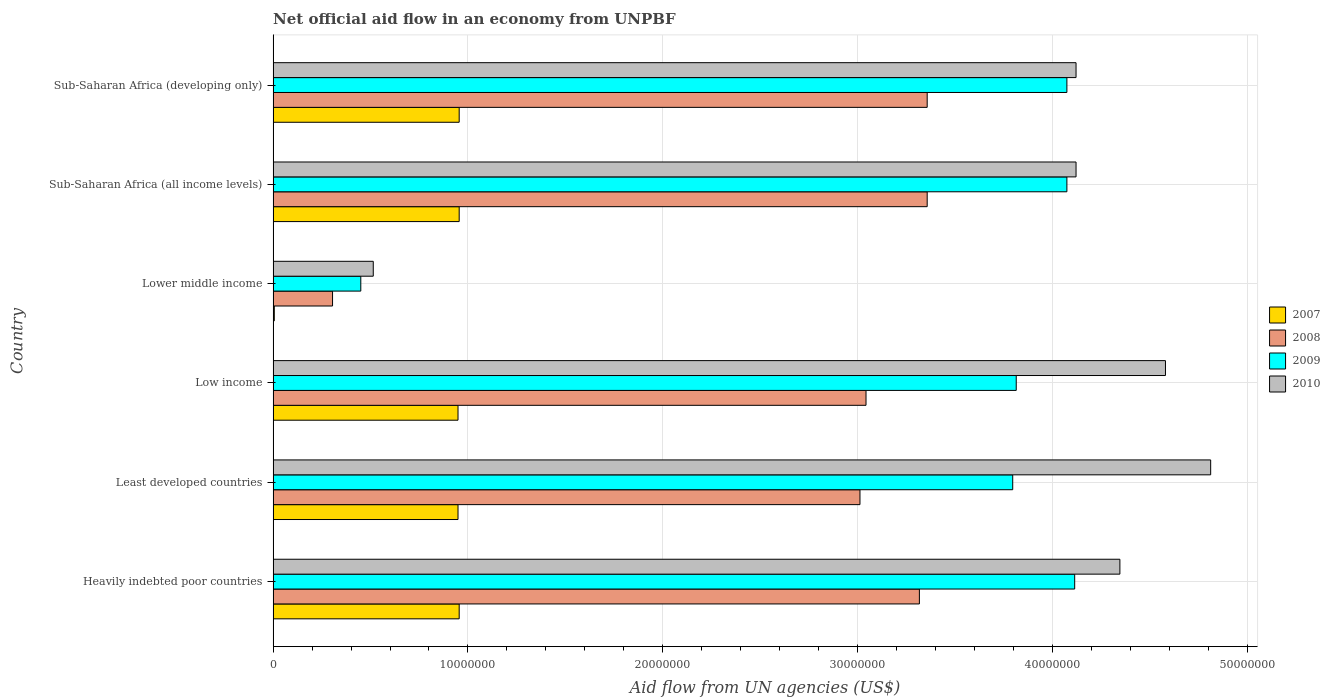How many groups of bars are there?
Your answer should be compact. 6. Are the number of bars per tick equal to the number of legend labels?
Offer a very short reply. Yes. Are the number of bars on each tick of the Y-axis equal?
Offer a terse response. Yes. How many bars are there on the 4th tick from the top?
Offer a terse response. 4. What is the net official aid flow in 2007 in Sub-Saharan Africa (developing only)?
Your answer should be compact. 9.55e+06. Across all countries, what is the maximum net official aid flow in 2010?
Give a very brief answer. 4.81e+07. Across all countries, what is the minimum net official aid flow in 2009?
Ensure brevity in your answer.  4.50e+06. In which country was the net official aid flow in 2010 maximum?
Offer a very short reply. Least developed countries. In which country was the net official aid flow in 2010 minimum?
Your answer should be very brief. Lower middle income. What is the total net official aid flow in 2008 in the graph?
Provide a short and direct response. 1.64e+08. What is the difference between the net official aid flow in 2007 in Low income and that in Sub-Saharan Africa (all income levels)?
Provide a succinct answer. -6.00e+04. What is the difference between the net official aid flow in 2007 in Heavily indebted poor countries and the net official aid flow in 2009 in Low income?
Your answer should be very brief. -2.86e+07. What is the average net official aid flow in 2010 per country?
Give a very brief answer. 3.75e+07. What is the difference between the net official aid flow in 2010 and net official aid flow in 2009 in Lower middle income?
Provide a short and direct response. 6.40e+05. In how many countries, is the net official aid flow in 2007 greater than 28000000 US$?
Offer a terse response. 0. What is the ratio of the net official aid flow in 2010 in Heavily indebted poor countries to that in Least developed countries?
Make the answer very short. 0.9. Is the net official aid flow in 2010 in Heavily indebted poor countries less than that in Low income?
Provide a short and direct response. Yes. Is the difference between the net official aid flow in 2010 in Sub-Saharan Africa (all income levels) and Sub-Saharan Africa (developing only) greater than the difference between the net official aid flow in 2009 in Sub-Saharan Africa (all income levels) and Sub-Saharan Africa (developing only)?
Your response must be concise. No. What is the difference between the highest and the second highest net official aid flow in 2010?
Your answer should be compact. 2.32e+06. What is the difference between the highest and the lowest net official aid flow in 2010?
Your answer should be compact. 4.30e+07. Is the sum of the net official aid flow in 2009 in Lower middle income and Sub-Saharan Africa (all income levels) greater than the maximum net official aid flow in 2010 across all countries?
Give a very brief answer. No. How many bars are there?
Offer a terse response. 24. What is the difference between two consecutive major ticks on the X-axis?
Provide a short and direct response. 1.00e+07. Are the values on the major ticks of X-axis written in scientific E-notation?
Your answer should be very brief. No. Does the graph contain any zero values?
Ensure brevity in your answer.  No. How are the legend labels stacked?
Offer a terse response. Vertical. What is the title of the graph?
Offer a very short reply. Net official aid flow in an economy from UNPBF. Does "1999" appear as one of the legend labels in the graph?
Your response must be concise. No. What is the label or title of the X-axis?
Offer a terse response. Aid flow from UN agencies (US$). What is the label or title of the Y-axis?
Provide a succinct answer. Country. What is the Aid flow from UN agencies (US$) of 2007 in Heavily indebted poor countries?
Make the answer very short. 9.55e+06. What is the Aid flow from UN agencies (US$) in 2008 in Heavily indebted poor countries?
Offer a very short reply. 3.32e+07. What is the Aid flow from UN agencies (US$) in 2009 in Heavily indebted poor countries?
Give a very brief answer. 4.11e+07. What is the Aid flow from UN agencies (US$) of 2010 in Heavily indebted poor countries?
Keep it short and to the point. 4.35e+07. What is the Aid flow from UN agencies (US$) in 2007 in Least developed countries?
Your response must be concise. 9.49e+06. What is the Aid flow from UN agencies (US$) of 2008 in Least developed countries?
Your answer should be compact. 3.01e+07. What is the Aid flow from UN agencies (US$) of 2009 in Least developed countries?
Your answer should be very brief. 3.80e+07. What is the Aid flow from UN agencies (US$) of 2010 in Least developed countries?
Offer a very short reply. 4.81e+07. What is the Aid flow from UN agencies (US$) in 2007 in Low income?
Keep it short and to the point. 9.49e+06. What is the Aid flow from UN agencies (US$) of 2008 in Low income?
Provide a short and direct response. 3.04e+07. What is the Aid flow from UN agencies (US$) of 2009 in Low income?
Provide a short and direct response. 3.81e+07. What is the Aid flow from UN agencies (US$) of 2010 in Low income?
Offer a terse response. 4.58e+07. What is the Aid flow from UN agencies (US$) of 2008 in Lower middle income?
Give a very brief answer. 3.05e+06. What is the Aid flow from UN agencies (US$) in 2009 in Lower middle income?
Give a very brief answer. 4.50e+06. What is the Aid flow from UN agencies (US$) in 2010 in Lower middle income?
Offer a terse response. 5.14e+06. What is the Aid flow from UN agencies (US$) of 2007 in Sub-Saharan Africa (all income levels)?
Offer a terse response. 9.55e+06. What is the Aid flow from UN agencies (US$) of 2008 in Sub-Saharan Africa (all income levels)?
Give a very brief answer. 3.36e+07. What is the Aid flow from UN agencies (US$) of 2009 in Sub-Saharan Africa (all income levels)?
Provide a short and direct response. 4.07e+07. What is the Aid flow from UN agencies (US$) in 2010 in Sub-Saharan Africa (all income levels)?
Your answer should be compact. 4.12e+07. What is the Aid flow from UN agencies (US$) of 2007 in Sub-Saharan Africa (developing only)?
Your response must be concise. 9.55e+06. What is the Aid flow from UN agencies (US$) in 2008 in Sub-Saharan Africa (developing only)?
Keep it short and to the point. 3.36e+07. What is the Aid flow from UN agencies (US$) of 2009 in Sub-Saharan Africa (developing only)?
Make the answer very short. 4.07e+07. What is the Aid flow from UN agencies (US$) of 2010 in Sub-Saharan Africa (developing only)?
Give a very brief answer. 4.12e+07. Across all countries, what is the maximum Aid flow from UN agencies (US$) of 2007?
Give a very brief answer. 9.55e+06. Across all countries, what is the maximum Aid flow from UN agencies (US$) in 2008?
Give a very brief answer. 3.36e+07. Across all countries, what is the maximum Aid flow from UN agencies (US$) of 2009?
Ensure brevity in your answer.  4.11e+07. Across all countries, what is the maximum Aid flow from UN agencies (US$) in 2010?
Offer a terse response. 4.81e+07. Across all countries, what is the minimum Aid flow from UN agencies (US$) in 2008?
Keep it short and to the point. 3.05e+06. Across all countries, what is the minimum Aid flow from UN agencies (US$) of 2009?
Keep it short and to the point. 4.50e+06. Across all countries, what is the minimum Aid flow from UN agencies (US$) in 2010?
Give a very brief answer. 5.14e+06. What is the total Aid flow from UN agencies (US$) in 2007 in the graph?
Make the answer very short. 4.77e+07. What is the total Aid flow from UN agencies (US$) of 2008 in the graph?
Provide a succinct answer. 1.64e+08. What is the total Aid flow from UN agencies (US$) in 2009 in the graph?
Keep it short and to the point. 2.03e+08. What is the total Aid flow from UN agencies (US$) of 2010 in the graph?
Ensure brevity in your answer.  2.25e+08. What is the difference between the Aid flow from UN agencies (US$) in 2007 in Heavily indebted poor countries and that in Least developed countries?
Your answer should be very brief. 6.00e+04. What is the difference between the Aid flow from UN agencies (US$) of 2008 in Heavily indebted poor countries and that in Least developed countries?
Provide a short and direct response. 3.05e+06. What is the difference between the Aid flow from UN agencies (US$) of 2009 in Heavily indebted poor countries and that in Least developed countries?
Your answer should be compact. 3.18e+06. What is the difference between the Aid flow from UN agencies (US$) in 2010 in Heavily indebted poor countries and that in Least developed countries?
Offer a very short reply. -4.66e+06. What is the difference between the Aid flow from UN agencies (US$) of 2007 in Heavily indebted poor countries and that in Low income?
Make the answer very short. 6.00e+04. What is the difference between the Aid flow from UN agencies (US$) in 2008 in Heavily indebted poor countries and that in Low income?
Your response must be concise. 2.74e+06. What is the difference between the Aid flow from UN agencies (US$) of 2009 in Heavily indebted poor countries and that in Low income?
Keep it short and to the point. 3.00e+06. What is the difference between the Aid flow from UN agencies (US$) of 2010 in Heavily indebted poor countries and that in Low income?
Your answer should be very brief. -2.34e+06. What is the difference between the Aid flow from UN agencies (US$) in 2007 in Heavily indebted poor countries and that in Lower middle income?
Offer a terse response. 9.49e+06. What is the difference between the Aid flow from UN agencies (US$) of 2008 in Heavily indebted poor countries and that in Lower middle income?
Your answer should be compact. 3.01e+07. What is the difference between the Aid flow from UN agencies (US$) in 2009 in Heavily indebted poor countries and that in Lower middle income?
Offer a very short reply. 3.66e+07. What is the difference between the Aid flow from UN agencies (US$) of 2010 in Heavily indebted poor countries and that in Lower middle income?
Your answer should be very brief. 3.83e+07. What is the difference between the Aid flow from UN agencies (US$) of 2008 in Heavily indebted poor countries and that in Sub-Saharan Africa (all income levels)?
Offer a terse response. -4.00e+05. What is the difference between the Aid flow from UN agencies (US$) in 2010 in Heavily indebted poor countries and that in Sub-Saharan Africa (all income levels)?
Keep it short and to the point. 2.25e+06. What is the difference between the Aid flow from UN agencies (US$) in 2007 in Heavily indebted poor countries and that in Sub-Saharan Africa (developing only)?
Keep it short and to the point. 0. What is the difference between the Aid flow from UN agencies (US$) of 2008 in Heavily indebted poor countries and that in Sub-Saharan Africa (developing only)?
Ensure brevity in your answer.  -4.00e+05. What is the difference between the Aid flow from UN agencies (US$) of 2010 in Heavily indebted poor countries and that in Sub-Saharan Africa (developing only)?
Offer a very short reply. 2.25e+06. What is the difference between the Aid flow from UN agencies (US$) of 2007 in Least developed countries and that in Low income?
Offer a terse response. 0. What is the difference between the Aid flow from UN agencies (US$) in 2008 in Least developed countries and that in Low income?
Offer a terse response. -3.10e+05. What is the difference between the Aid flow from UN agencies (US$) in 2009 in Least developed countries and that in Low income?
Give a very brief answer. -1.80e+05. What is the difference between the Aid flow from UN agencies (US$) in 2010 in Least developed countries and that in Low income?
Your answer should be compact. 2.32e+06. What is the difference between the Aid flow from UN agencies (US$) of 2007 in Least developed countries and that in Lower middle income?
Your response must be concise. 9.43e+06. What is the difference between the Aid flow from UN agencies (US$) of 2008 in Least developed countries and that in Lower middle income?
Your response must be concise. 2.71e+07. What is the difference between the Aid flow from UN agencies (US$) in 2009 in Least developed countries and that in Lower middle income?
Your answer should be compact. 3.35e+07. What is the difference between the Aid flow from UN agencies (US$) of 2010 in Least developed countries and that in Lower middle income?
Offer a very short reply. 4.30e+07. What is the difference between the Aid flow from UN agencies (US$) in 2007 in Least developed countries and that in Sub-Saharan Africa (all income levels)?
Your answer should be compact. -6.00e+04. What is the difference between the Aid flow from UN agencies (US$) in 2008 in Least developed countries and that in Sub-Saharan Africa (all income levels)?
Make the answer very short. -3.45e+06. What is the difference between the Aid flow from UN agencies (US$) in 2009 in Least developed countries and that in Sub-Saharan Africa (all income levels)?
Your answer should be very brief. -2.78e+06. What is the difference between the Aid flow from UN agencies (US$) in 2010 in Least developed countries and that in Sub-Saharan Africa (all income levels)?
Your answer should be very brief. 6.91e+06. What is the difference between the Aid flow from UN agencies (US$) of 2007 in Least developed countries and that in Sub-Saharan Africa (developing only)?
Keep it short and to the point. -6.00e+04. What is the difference between the Aid flow from UN agencies (US$) of 2008 in Least developed countries and that in Sub-Saharan Africa (developing only)?
Offer a very short reply. -3.45e+06. What is the difference between the Aid flow from UN agencies (US$) of 2009 in Least developed countries and that in Sub-Saharan Africa (developing only)?
Provide a short and direct response. -2.78e+06. What is the difference between the Aid flow from UN agencies (US$) of 2010 in Least developed countries and that in Sub-Saharan Africa (developing only)?
Offer a very short reply. 6.91e+06. What is the difference between the Aid flow from UN agencies (US$) of 2007 in Low income and that in Lower middle income?
Provide a succinct answer. 9.43e+06. What is the difference between the Aid flow from UN agencies (US$) in 2008 in Low income and that in Lower middle income?
Ensure brevity in your answer.  2.74e+07. What is the difference between the Aid flow from UN agencies (US$) in 2009 in Low income and that in Lower middle income?
Make the answer very short. 3.36e+07. What is the difference between the Aid flow from UN agencies (US$) of 2010 in Low income and that in Lower middle income?
Offer a terse response. 4.07e+07. What is the difference between the Aid flow from UN agencies (US$) of 2008 in Low income and that in Sub-Saharan Africa (all income levels)?
Make the answer very short. -3.14e+06. What is the difference between the Aid flow from UN agencies (US$) in 2009 in Low income and that in Sub-Saharan Africa (all income levels)?
Ensure brevity in your answer.  -2.60e+06. What is the difference between the Aid flow from UN agencies (US$) in 2010 in Low income and that in Sub-Saharan Africa (all income levels)?
Make the answer very short. 4.59e+06. What is the difference between the Aid flow from UN agencies (US$) in 2007 in Low income and that in Sub-Saharan Africa (developing only)?
Provide a short and direct response. -6.00e+04. What is the difference between the Aid flow from UN agencies (US$) of 2008 in Low income and that in Sub-Saharan Africa (developing only)?
Offer a very short reply. -3.14e+06. What is the difference between the Aid flow from UN agencies (US$) in 2009 in Low income and that in Sub-Saharan Africa (developing only)?
Ensure brevity in your answer.  -2.60e+06. What is the difference between the Aid flow from UN agencies (US$) in 2010 in Low income and that in Sub-Saharan Africa (developing only)?
Provide a short and direct response. 4.59e+06. What is the difference between the Aid flow from UN agencies (US$) in 2007 in Lower middle income and that in Sub-Saharan Africa (all income levels)?
Offer a very short reply. -9.49e+06. What is the difference between the Aid flow from UN agencies (US$) of 2008 in Lower middle income and that in Sub-Saharan Africa (all income levels)?
Make the answer very short. -3.05e+07. What is the difference between the Aid flow from UN agencies (US$) of 2009 in Lower middle income and that in Sub-Saharan Africa (all income levels)?
Your answer should be very brief. -3.62e+07. What is the difference between the Aid flow from UN agencies (US$) in 2010 in Lower middle income and that in Sub-Saharan Africa (all income levels)?
Offer a very short reply. -3.61e+07. What is the difference between the Aid flow from UN agencies (US$) in 2007 in Lower middle income and that in Sub-Saharan Africa (developing only)?
Offer a very short reply. -9.49e+06. What is the difference between the Aid flow from UN agencies (US$) in 2008 in Lower middle income and that in Sub-Saharan Africa (developing only)?
Provide a short and direct response. -3.05e+07. What is the difference between the Aid flow from UN agencies (US$) of 2009 in Lower middle income and that in Sub-Saharan Africa (developing only)?
Provide a short and direct response. -3.62e+07. What is the difference between the Aid flow from UN agencies (US$) in 2010 in Lower middle income and that in Sub-Saharan Africa (developing only)?
Offer a terse response. -3.61e+07. What is the difference between the Aid flow from UN agencies (US$) of 2009 in Sub-Saharan Africa (all income levels) and that in Sub-Saharan Africa (developing only)?
Give a very brief answer. 0. What is the difference between the Aid flow from UN agencies (US$) in 2007 in Heavily indebted poor countries and the Aid flow from UN agencies (US$) in 2008 in Least developed countries?
Your answer should be very brief. -2.06e+07. What is the difference between the Aid flow from UN agencies (US$) of 2007 in Heavily indebted poor countries and the Aid flow from UN agencies (US$) of 2009 in Least developed countries?
Provide a succinct answer. -2.84e+07. What is the difference between the Aid flow from UN agencies (US$) in 2007 in Heavily indebted poor countries and the Aid flow from UN agencies (US$) in 2010 in Least developed countries?
Ensure brevity in your answer.  -3.86e+07. What is the difference between the Aid flow from UN agencies (US$) in 2008 in Heavily indebted poor countries and the Aid flow from UN agencies (US$) in 2009 in Least developed countries?
Ensure brevity in your answer.  -4.79e+06. What is the difference between the Aid flow from UN agencies (US$) in 2008 in Heavily indebted poor countries and the Aid flow from UN agencies (US$) in 2010 in Least developed countries?
Provide a short and direct response. -1.50e+07. What is the difference between the Aid flow from UN agencies (US$) in 2009 in Heavily indebted poor countries and the Aid flow from UN agencies (US$) in 2010 in Least developed countries?
Give a very brief answer. -6.98e+06. What is the difference between the Aid flow from UN agencies (US$) in 2007 in Heavily indebted poor countries and the Aid flow from UN agencies (US$) in 2008 in Low income?
Your response must be concise. -2.09e+07. What is the difference between the Aid flow from UN agencies (US$) in 2007 in Heavily indebted poor countries and the Aid flow from UN agencies (US$) in 2009 in Low income?
Keep it short and to the point. -2.86e+07. What is the difference between the Aid flow from UN agencies (US$) of 2007 in Heavily indebted poor countries and the Aid flow from UN agencies (US$) of 2010 in Low income?
Provide a short and direct response. -3.62e+07. What is the difference between the Aid flow from UN agencies (US$) in 2008 in Heavily indebted poor countries and the Aid flow from UN agencies (US$) in 2009 in Low income?
Give a very brief answer. -4.97e+06. What is the difference between the Aid flow from UN agencies (US$) in 2008 in Heavily indebted poor countries and the Aid flow from UN agencies (US$) in 2010 in Low income?
Your response must be concise. -1.26e+07. What is the difference between the Aid flow from UN agencies (US$) in 2009 in Heavily indebted poor countries and the Aid flow from UN agencies (US$) in 2010 in Low income?
Keep it short and to the point. -4.66e+06. What is the difference between the Aid flow from UN agencies (US$) in 2007 in Heavily indebted poor countries and the Aid flow from UN agencies (US$) in 2008 in Lower middle income?
Provide a short and direct response. 6.50e+06. What is the difference between the Aid flow from UN agencies (US$) in 2007 in Heavily indebted poor countries and the Aid flow from UN agencies (US$) in 2009 in Lower middle income?
Your answer should be very brief. 5.05e+06. What is the difference between the Aid flow from UN agencies (US$) of 2007 in Heavily indebted poor countries and the Aid flow from UN agencies (US$) of 2010 in Lower middle income?
Offer a very short reply. 4.41e+06. What is the difference between the Aid flow from UN agencies (US$) in 2008 in Heavily indebted poor countries and the Aid flow from UN agencies (US$) in 2009 in Lower middle income?
Ensure brevity in your answer.  2.87e+07. What is the difference between the Aid flow from UN agencies (US$) of 2008 in Heavily indebted poor countries and the Aid flow from UN agencies (US$) of 2010 in Lower middle income?
Provide a succinct answer. 2.80e+07. What is the difference between the Aid flow from UN agencies (US$) in 2009 in Heavily indebted poor countries and the Aid flow from UN agencies (US$) in 2010 in Lower middle income?
Offer a terse response. 3.60e+07. What is the difference between the Aid flow from UN agencies (US$) in 2007 in Heavily indebted poor countries and the Aid flow from UN agencies (US$) in 2008 in Sub-Saharan Africa (all income levels)?
Your response must be concise. -2.40e+07. What is the difference between the Aid flow from UN agencies (US$) of 2007 in Heavily indebted poor countries and the Aid flow from UN agencies (US$) of 2009 in Sub-Saharan Africa (all income levels)?
Offer a very short reply. -3.12e+07. What is the difference between the Aid flow from UN agencies (US$) of 2007 in Heavily indebted poor countries and the Aid flow from UN agencies (US$) of 2010 in Sub-Saharan Africa (all income levels)?
Your answer should be compact. -3.17e+07. What is the difference between the Aid flow from UN agencies (US$) in 2008 in Heavily indebted poor countries and the Aid flow from UN agencies (US$) in 2009 in Sub-Saharan Africa (all income levels)?
Make the answer very short. -7.57e+06. What is the difference between the Aid flow from UN agencies (US$) in 2008 in Heavily indebted poor countries and the Aid flow from UN agencies (US$) in 2010 in Sub-Saharan Africa (all income levels)?
Provide a succinct answer. -8.04e+06. What is the difference between the Aid flow from UN agencies (US$) in 2007 in Heavily indebted poor countries and the Aid flow from UN agencies (US$) in 2008 in Sub-Saharan Africa (developing only)?
Your response must be concise. -2.40e+07. What is the difference between the Aid flow from UN agencies (US$) in 2007 in Heavily indebted poor countries and the Aid flow from UN agencies (US$) in 2009 in Sub-Saharan Africa (developing only)?
Ensure brevity in your answer.  -3.12e+07. What is the difference between the Aid flow from UN agencies (US$) in 2007 in Heavily indebted poor countries and the Aid flow from UN agencies (US$) in 2010 in Sub-Saharan Africa (developing only)?
Your response must be concise. -3.17e+07. What is the difference between the Aid flow from UN agencies (US$) of 2008 in Heavily indebted poor countries and the Aid flow from UN agencies (US$) of 2009 in Sub-Saharan Africa (developing only)?
Your answer should be compact. -7.57e+06. What is the difference between the Aid flow from UN agencies (US$) of 2008 in Heavily indebted poor countries and the Aid flow from UN agencies (US$) of 2010 in Sub-Saharan Africa (developing only)?
Your answer should be compact. -8.04e+06. What is the difference between the Aid flow from UN agencies (US$) in 2007 in Least developed countries and the Aid flow from UN agencies (US$) in 2008 in Low income?
Keep it short and to the point. -2.09e+07. What is the difference between the Aid flow from UN agencies (US$) of 2007 in Least developed countries and the Aid flow from UN agencies (US$) of 2009 in Low income?
Your answer should be very brief. -2.86e+07. What is the difference between the Aid flow from UN agencies (US$) of 2007 in Least developed countries and the Aid flow from UN agencies (US$) of 2010 in Low income?
Your response must be concise. -3.63e+07. What is the difference between the Aid flow from UN agencies (US$) of 2008 in Least developed countries and the Aid flow from UN agencies (US$) of 2009 in Low income?
Your response must be concise. -8.02e+06. What is the difference between the Aid flow from UN agencies (US$) in 2008 in Least developed countries and the Aid flow from UN agencies (US$) in 2010 in Low income?
Give a very brief answer. -1.57e+07. What is the difference between the Aid flow from UN agencies (US$) of 2009 in Least developed countries and the Aid flow from UN agencies (US$) of 2010 in Low income?
Your answer should be compact. -7.84e+06. What is the difference between the Aid flow from UN agencies (US$) in 2007 in Least developed countries and the Aid flow from UN agencies (US$) in 2008 in Lower middle income?
Offer a very short reply. 6.44e+06. What is the difference between the Aid flow from UN agencies (US$) in 2007 in Least developed countries and the Aid flow from UN agencies (US$) in 2009 in Lower middle income?
Offer a terse response. 4.99e+06. What is the difference between the Aid flow from UN agencies (US$) of 2007 in Least developed countries and the Aid flow from UN agencies (US$) of 2010 in Lower middle income?
Your response must be concise. 4.35e+06. What is the difference between the Aid flow from UN agencies (US$) of 2008 in Least developed countries and the Aid flow from UN agencies (US$) of 2009 in Lower middle income?
Keep it short and to the point. 2.56e+07. What is the difference between the Aid flow from UN agencies (US$) of 2008 in Least developed countries and the Aid flow from UN agencies (US$) of 2010 in Lower middle income?
Your response must be concise. 2.50e+07. What is the difference between the Aid flow from UN agencies (US$) in 2009 in Least developed countries and the Aid flow from UN agencies (US$) in 2010 in Lower middle income?
Make the answer very short. 3.28e+07. What is the difference between the Aid flow from UN agencies (US$) in 2007 in Least developed countries and the Aid flow from UN agencies (US$) in 2008 in Sub-Saharan Africa (all income levels)?
Give a very brief answer. -2.41e+07. What is the difference between the Aid flow from UN agencies (US$) in 2007 in Least developed countries and the Aid flow from UN agencies (US$) in 2009 in Sub-Saharan Africa (all income levels)?
Make the answer very short. -3.12e+07. What is the difference between the Aid flow from UN agencies (US$) of 2007 in Least developed countries and the Aid flow from UN agencies (US$) of 2010 in Sub-Saharan Africa (all income levels)?
Offer a terse response. -3.17e+07. What is the difference between the Aid flow from UN agencies (US$) of 2008 in Least developed countries and the Aid flow from UN agencies (US$) of 2009 in Sub-Saharan Africa (all income levels)?
Provide a short and direct response. -1.06e+07. What is the difference between the Aid flow from UN agencies (US$) in 2008 in Least developed countries and the Aid flow from UN agencies (US$) in 2010 in Sub-Saharan Africa (all income levels)?
Your answer should be compact. -1.11e+07. What is the difference between the Aid flow from UN agencies (US$) of 2009 in Least developed countries and the Aid flow from UN agencies (US$) of 2010 in Sub-Saharan Africa (all income levels)?
Ensure brevity in your answer.  -3.25e+06. What is the difference between the Aid flow from UN agencies (US$) of 2007 in Least developed countries and the Aid flow from UN agencies (US$) of 2008 in Sub-Saharan Africa (developing only)?
Give a very brief answer. -2.41e+07. What is the difference between the Aid flow from UN agencies (US$) in 2007 in Least developed countries and the Aid flow from UN agencies (US$) in 2009 in Sub-Saharan Africa (developing only)?
Your response must be concise. -3.12e+07. What is the difference between the Aid flow from UN agencies (US$) of 2007 in Least developed countries and the Aid flow from UN agencies (US$) of 2010 in Sub-Saharan Africa (developing only)?
Provide a short and direct response. -3.17e+07. What is the difference between the Aid flow from UN agencies (US$) of 2008 in Least developed countries and the Aid flow from UN agencies (US$) of 2009 in Sub-Saharan Africa (developing only)?
Keep it short and to the point. -1.06e+07. What is the difference between the Aid flow from UN agencies (US$) of 2008 in Least developed countries and the Aid flow from UN agencies (US$) of 2010 in Sub-Saharan Africa (developing only)?
Offer a very short reply. -1.11e+07. What is the difference between the Aid flow from UN agencies (US$) of 2009 in Least developed countries and the Aid flow from UN agencies (US$) of 2010 in Sub-Saharan Africa (developing only)?
Your answer should be very brief. -3.25e+06. What is the difference between the Aid flow from UN agencies (US$) in 2007 in Low income and the Aid flow from UN agencies (US$) in 2008 in Lower middle income?
Provide a succinct answer. 6.44e+06. What is the difference between the Aid flow from UN agencies (US$) of 2007 in Low income and the Aid flow from UN agencies (US$) of 2009 in Lower middle income?
Your answer should be very brief. 4.99e+06. What is the difference between the Aid flow from UN agencies (US$) in 2007 in Low income and the Aid flow from UN agencies (US$) in 2010 in Lower middle income?
Your response must be concise. 4.35e+06. What is the difference between the Aid flow from UN agencies (US$) in 2008 in Low income and the Aid flow from UN agencies (US$) in 2009 in Lower middle income?
Offer a terse response. 2.59e+07. What is the difference between the Aid flow from UN agencies (US$) in 2008 in Low income and the Aid flow from UN agencies (US$) in 2010 in Lower middle income?
Make the answer very short. 2.53e+07. What is the difference between the Aid flow from UN agencies (US$) of 2009 in Low income and the Aid flow from UN agencies (US$) of 2010 in Lower middle income?
Offer a very short reply. 3.30e+07. What is the difference between the Aid flow from UN agencies (US$) of 2007 in Low income and the Aid flow from UN agencies (US$) of 2008 in Sub-Saharan Africa (all income levels)?
Keep it short and to the point. -2.41e+07. What is the difference between the Aid flow from UN agencies (US$) in 2007 in Low income and the Aid flow from UN agencies (US$) in 2009 in Sub-Saharan Africa (all income levels)?
Provide a short and direct response. -3.12e+07. What is the difference between the Aid flow from UN agencies (US$) in 2007 in Low income and the Aid flow from UN agencies (US$) in 2010 in Sub-Saharan Africa (all income levels)?
Offer a terse response. -3.17e+07. What is the difference between the Aid flow from UN agencies (US$) in 2008 in Low income and the Aid flow from UN agencies (US$) in 2009 in Sub-Saharan Africa (all income levels)?
Offer a terse response. -1.03e+07. What is the difference between the Aid flow from UN agencies (US$) of 2008 in Low income and the Aid flow from UN agencies (US$) of 2010 in Sub-Saharan Africa (all income levels)?
Offer a very short reply. -1.08e+07. What is the difference between the Aid flow from UN agencies (US$) of 2009 in Low income and the Aid flow from UN agencies (US$) of 2010 in Sub-Saharan Africa (all income levels)?
Offer a terse response. -3.07e+06. What is the difference between the Aid flow from UN agencies (US$) of 2007 in Low income and the Aid flow from UN agencies (US$) of 2008 in Sub-Saharan Africa (developing only)?
Provide a short and direct response. -2.41e+07. What is the difference between the Aid flow from UN agencies (US$) of 2007 in Low income and the Aid flow from UN agencies (US$) of 2009 in Sub-Saharan Africa (developing only)?
Ensure brevity in your answer.  -3.12e+07. What is the difference between the Aid flow from UN agencies (US$) of 2007 in Low income and the Aid flow from UN agencies (US$) of 2010 in Sub-Saharan Africa (developing only)?
Ensure brevity in your answer.  -3.17e+07. What is the difference between the Aid flow from UN agencies (US$) of 2008 in Low income and the Aid flow from UN agencies (US$) of 2009 in Sub-Saharan Africa (developing only)?
Offer a terse response. -1.03e+07. What is the difference between the Aid flow from UN agencies (US$) in 2008 in Low income and the Aid flow from UN agencies (US$) in 2010 in Sub-Saharan Africa (developing only)?
Keep it short and to the point. -1.08e+07. What is the difference between the Aid flow from UN agencies (US$) in 2009 in Low income and the Aid flow from UN agencies (US$) in 2010 in Sub-Saharan Africa (developing only)?
Offer a terse response. -3.07e+06. What is the difference between the Aid flow from UN agencies (US$) of 2007 in Lower middle income and the Aid flow from UN agencies (US$) of 2008 in Sub-Saharan Africa (all income levels)?
Ensure brevity in your answer.  -3.35e+07. What is the difference between the Aid flow from UN agencies (US$) of 2007 in Lower middle income and the Aid flow from UN agencies (US$) of 2009 in Sub-Saharan Africa (all income levels)?
Give a very brief answer. -4.07e+07. What is the difference between the Aid flow from UN agencies (US$) of 2007 in Lower middle income and the Aid flow from UN agencies (US$) of 2010 in Sub-Saharan Africa (all income levels)?
Ensure brevity in your answer.  -4.12e+07. What is the difference between the Aid flow from UN agencies (US$) in 2008 in Lower middle income and the Aid flow from UN agencies (US$) in 2009 in Sub-Saharan Africa (all income levels)?
Your answer should be very brief. -3.77e+07. What is the difference between the Aid flow from UN agencies (US$) of 2008 in Lower middle income and the Aid flow from UN agencies (US$) of 2010 in Sub-Saharan Africa (all income levels)?
Provide a succinct answer. -3.82e+07. What is the difference between the Aid flow from UN agencies (US$) of 2009 in Lower middle income and the Aid flow from UN agencies (US$) of 2010 in Sub-Saharan Africa (all income levels)?
Make the answer very short. -3.67e+07. What is the difference between the Aid flow from UN agencies (US$) in 2007 in Lower middle income and the Aid flow from UN agencies (US$) in 2008 in Sub-Saharan Africa (developing only)?
Your answer should be compact. -3.35e+07. What is the difference between the Aid flow from UN agencies (US$) in 2007 in Lower middle income and the Aid flow from UN agencies (US$) in 2009 in Sub-Saharan Africa (developing only)?
Provide a short and direct response. -4.07e+07. What is the difference between the Aid flow from UN agencies (US$) in 2007 in Lower middle income and the Aid flow from UN agencies (US$) in 2010 in Sub-Saharan Africa (developing only)?
Provide a short and direct response. -4.12e+07. What is the difference between the Aid flow from UN agencies (US$) in 2008 in Lower middle income and the Aid flow from UN agencies (US$) in 2009 in Sub-Saharan Africa (developing only)?
Provide a succinct answer. -3.77e+07. What is the difference between the Aid flow from UN agencies (US$) of 2008 in Lower middle income and the Aid flow from UN agencies (US$) of 2010 in Sub-Saharan Africa (developing only)?
Make the answer very short. -3.82e+07. What is the difference between the Aid flow from UN agencies (US$) in 2009 in Lower middle income and the Aid flow from UN agencies (US$) in 2010 in Sub-Saharan Africa (developing only)?
Offer a terse response. -3.67e+07. What is the difference between the Aid flow from UN agencies (US$) of 2007 in Sub-Saharan Africa (all income levels) and the Aid flow from UN agencies (US$) of 2008 in Sub-Saharan Africa (developing only)?
Offer a very short reply. -2.40e+07. What is the difference between the Aid flow from UN agencies (US$) in 2007 in Sub-Saharan Africa (all income levels) and the Aid flow from UN agencies (US$) in 2009 in Sub-Saharan Africa (developing only)?
Your response must be concise. -3.12e+07. What is the difference between the Aid flow from UN agencies (US$) in 2007 in Sub-Saharan Africa (all income levels) and the Aid flow from UN agencies (US$) in 2010 in Sub-Saharan Africa (developing only)?
Keep it short and to the point. -3.17e+07. What is the difference between the Aid flow from UN agencies (US$) of 2008 in Sub-Saharan Africa (all income levels) and the Aid flow from UN agencies (US$) of 2009 in Sub-Saharan Africa (developing only)?
Offer a terse response. -7.17e+06. What is the difference between the Aid flow from UN agencies (US$) in 2008 in Sub-Saharan Africa (all income levels) and the Aid flow from UN agencies (US$) in 2010 in Sub-Saharan Africa (developing only)?
Provide a short and direct response. -7.64e+06. What is the difference between the Aid flow from UN agencies (US$) in 2009 in Sub-Saharan Africa (all income levels) and the Aid flow from UN agencies (US$) in 2010 in Sub-Saharan Africa (developing only)?
Your answer should be very brief. -4.70e+05. What is the average Aid flow from UN agencies (US$) in 2007 per country?
Provide a succinct answer. 7.95e+06. What is the average Aid flow from UN agencies (US$) in 2008 per country?
Provide a succinct answer. 2.73e+07. What is the average Aid flow from UN agencies (US$) in 2009 per country?
Provide a succinct answer. 3.39e+07. What is the average Aid flow from UN agencies (US$) of 2010 per country?
Your answer should be compact. 3.75e+07. What is the difference between the Aid flow from UN agencies (US$) of 2007 and Aid flow from UN agencies (US$) of 2008 in Heavily indebted poor countries?
Provide a succinct answer. -2.36e+07. What is the difference between the Aid flow from UN agencies (US$) in 2007 and Aid flow from UN agencies (US$) in 2009 in Heavily indebted poor countries?
Your response must be concise. -3.16e+07. What is the difference between the Aid flow from UN agencies (US$) in 2007 and Aid flow from UN agencies (US$) in 2010 in Heavily indebted poor countries?
Your answer should be very brief. -3.39e+07. What is the difference between the Aid flow from UN agencies (US$) of 2008 and Aid flow from UN agencies (US$) of 2009 in Heavily indebted poor countries?
Provide a short and direct response. -7.97e+06. What is the difference between the Aid flow from UN agencies (US$) of 2008 and Aid flow from UN agencies (US$) of 2010 in Heavily indebted poor countries?
Your answer should be compact. -1.03e+07. What is the difference between the Aid flow from UN agencies (US$) in 2009 and Aid flow from UN agencies (US$) in 2010 in Heavily indebted poor countries?
Offer a very short reply. -2.32e+06. What is the difference between the Aid flow from UN agencies (US$) of 2007 and Aid flow from UN agencies (US$) of 2008 in Least developed countries?
Ensure brevity in your answer.  -2.06e+07. What is the difference between the Aid flow from UN agencies (US$) of 2007 and Aid flow from UN agencies (US$) of 2009 in Least developed countries?
Your answer should be very brief. -2.85e+07. What is the difference between the Aid flow from UN agencies (US$) of 2007 and Aid flow from UN agencies (US$) of 2010 in Least developed countries?
Offer a very short reply. -3.86e+07. What is the difference between the Aid flow from UN agencies (US$) in 2008 and Aid flow from UN agencies (US$) in 2009 in Least developed countries?
Your answer should be compact. -7.84e+06. What is the difference between the Aid flow from UN agencies (US$) in 2008 and Aid flow from UN agencies (US$) in 2010 in Least developed countries?
Ensure brevity in your answer.  -1.80e+07. What is the difference between the Aid flow from UN agencies (US$) in 2009 and Aid flow from UN agencies (US$) in 2010 in Least developed countries?
Make the answer very short. -1.02e+07. What is the difference between the Aid flow from UN agencies (US$) in 2007 and Aid flow from UN agencies (US$) in 2008 in Low income?
Your answer should be very brief. -2.09e+07. What is the difference between the Aid flow from UN agencies (US$) in 2007 and Aid flow from UN agencies (US$) in 2009 in Low income?
Keep it short and to the point. -2.86e+07. What is the difference between the Aid flow from UN agencies (US$) of 2007 and Aid flow from UN agencies (US$) of 2010 in Low income?
Your response must be concise. -3.63e+07. What is the difference between the Aid flow from UN agencies (US$) of 2008 and Aid flow from UN agencies (US$) of 2009 in Low income?
Make the answer very short. -7.71e+06. What is the difference between the Aid flow from UN agencies (US$) in 2008 and Aid flow from UN agencies (US$) in 2010 in Low income?
Your answer should be very brief. -1.54e+07. What is the difference between the Aid flow from UN agencies (US$) of 2009 and Aid flow from UN agencies (US$) of 2010 in Low income?
Your response must be concise. -7.66e+06. What is the difference between the Aid flow from UN agencies (US$) of 2007 and Aid flow from UN agencies (US$) of 2008 in Lower middle income?
Make the answer very short. -2.99e+06. What is the difference between the Aid flow from UN agencies (US$) of 2007 and Aid flow from UN agencies (US$) of 2009 in Lower middle income?
Your answer should be very brief. -4.44e+06. What is the difference between the Aid flow from UN agencies (US$) of 2007 and Aid flow from UN agencies (US$) of 2010 in Lower middle income?
Keep it short and to the point. -5.08e+06. What is the difference between the Aid flow from UN agencies (US$) in 2008 and Aid flow from UN agencies (US$) in 2009 in Lower middle income?
Keep it short and to the point. -1.45e+06. What is the difference between the Aid flow from UN agencies (US$) in 2008 and Aid flow from UN agencies (US$) in 2010 in Lower middle income?
Your answer should be compact. -2.09e+06. What is the difference between the Aid flow from UN agencies (US$) in 2009 and Aid flow from UN agencies (US$) in 2010 in Lower middle income?
Ensure brevity in your answer.  -6.40e+05. What is the difference between the Aid flow from UN agencies (US$) of 2007 and Aid flow from UN agencies (US$) of 2008 in Sub-Saharan Africa (all income levels)?
Your answer should be compact. -2.40e+07. What is the difference between the Aid flow from UN agencies (US$) of 2007 and Aid flow from UN agencies (US$) of 2009 in Sub-Saharan Africa (all income levels)?
Offer a very short reply. -3.12e+07. What is the difference between the Aid flow from UN agencies (US$) of 2007 and Aid flow from UN agencies (US$) of 2010 in Sub-Saharan Africa (all income levels)?
Your answer should be compact. -3.17e+07. What is the difference between the Aid flow from UN agencies (US$) in 2008 and Aid flow from UN agencies (US$) in 2009 in Sub-Saharan Africa (all income levels)?
Ensure brevity in your answer.  -7.17e+06. What is the difference between the Aid flow from UN agencies (US$) in 2008 and Aid flow from UN agencies (US$) in 2010 in Sub-Saharan Africa (all income levels)?
Keep it short and to the point. -7.64e+06. What is the difference between the Aid flow from UN agencies (US$) of 2009 and Aid flow from UN agencies (US$) of 2010 in Sub-Saharan Africa (all income levels)?
Provide a succinct answer. -4.70e+05. What is the difference between the Aid flow from UN agencies (US$) in 2007 and Aid flow from UN agencies (US$) in 2008 in Sub-Saharan Africa (developing only)?
Provide a short and direct response. -2.40e+07. What is the difference between the Aid flow from UN agencies (US$) of 2007 and Aid flow from UN agencies (US$) of 2009 in Sub-Saharan Africa (developing only)?
Your answer should be very brief. -3.12e+07. What is the difference between the Aid flow from UN agencies (US$) in 2007 and Aid flow from UN agencies (US$) in 2010 in Sub-Saharan Africa (developing only)?
Provide a short and direct response. -3.17e+07. What is the difference between the Aid flow from UN agencies (US$) of 2008 and Aid flow from UN agencies (US$) of 2009 in Sub-Saharan Africa (developing only)?
Your response must be concise. -7.17e+06. What is the difference between the Aid flow from UN agencies (US$) of 2008 and Aid flow from UN agencies (US$) of 2010 in Sub-Saharan Africa (developing only)?
Offer a terse response. -7.64e+06. What is the difference between the Aid flow from UN agencies (US$) in 2009 and Aid flow from UN agencies (US$) in 2010 in Sub-Saharan Africa (developing only)?
Your answer should be very brief. -4.70e+05. What is the ratio of the Aid flow from UN agencies (US$) in 2007 in Heavily indebted poor countries to that in Least developed countries?
Provide a short and direct response. 1.01. What is the ratio of the Aid flow from UN agencies (US$) of 2008 in Heavily indebted poor countries to that in Least developed countries?
Provide a succinct answer. 1.1. What is the ratio of the Aid flow from UN agencies (US$) of 2009 in Heavily indebted poor countries to that in Least developed countries?
Your answer should be very brief. 1.08. What is the ratio of the Aid flow from UN agencies (US$) in 2010 in Heavily indebted poor countries to that in Least developed countries?
Provide a succinct answer. 0.9. What is the ratio of the Aid flow from UN agencies (US$) of 2008 in Heavily indebted poor countries to that in Low income?
Give a very brief answer. 1.09. What is the ratio of the Aid flow from UN agencies (US$) of 2009 in Heavily indebted poor countries to that in Low income?
Ensure brevity in your answer.  1.08. What is the ratio of the Aid flow from UN agencies (US$) in 2010 in Heavily indebted poor countries to that in Low income?
Offer a terse response. 0.95. What is the ratio of the Aid flow from UN agencies (US$) in 2007 in Heavily indebted poor countries to that in Lower middle income?
Provide a short and direct response. 159.17. What is the ratio of the Aid flow from UN agencies (US$) of 2008 in Heavily indebted poor countries to that in Lower middle income?
Keep it short and to the point. 10.88. What is the ratio of the Aid flow from UN agencies (US$) of 2009 in Heavily indebted poor countries to that in Lower middle income?
Make the answer very short. 9.14. What is the ratio of the Aid flow from UN agencies (US$) of 2010 in Heavily indebted poor countries to that in Lower middle income?
Ensure brevity in your answer.  8.46. What is the ratio of the Aid flow from UN agencies (US$) of 2007 in Heavily indebted poor countries to that in Sub-Saharan Africa (all income levels)?
Make the answer very short. 1. What is the ratio of the Aid flow from UN agencies (US$) in 2008 in Heavily indebted poor countries to that in Sub-Saharan Africa (all income levels)?
Your answer should be very brief. 0.99. What is the ratio of the Aid flow from UN agencies (US$) in 2009 in Heavily indebted poor countries to that in Sub-Saharan Africa (all income levels)?
Your answer should be very brief. 1.01. What is the ratio of the Aid flow from UN agencies (US$) in 2010 in Heavily indebted poor countries to that in Sub-Saharan Africa (all income levels)?
Offer a terse response. 1.05. What is the ratio of the Aid flow from UN agencies (US$) in 2007 in Heavily indebted poor countries to that in Sub-Saharan Africa (developing only)?
Offer a terse response. 1. What is the ratio of the Aid flow from UN agencies (US$) of 2009 in Heavily indebted poor countries to that in Sub-Saharan Africa (developing only)?
Make the answer very short. 1.01. What is the ratio of the Aid flow from UN agencies (US$) in 2010 in Heavily indebted poor countries to that in Sub-Saharan Africa (developing only)?
Your response must be concise. 1.05. What is the ratio of the Aid flow from UN agencies (US$) in 2007 in Least developed countries to that in Low income?
Make the answer very short. 1. What is the ratio of the Aid flow from UN agencies (US$) of 2009 in Least developed countries to that in Low income?
Offer a terse response. 1. What is the ratio of the Aid flow from UN agencies (US$) in 2010 in Least developed countries to that in Low income?
Your answer should be compact. 1.05. What is the ratio of the Aid flow from UN agencies (US$) of 2007 in Least developed countries to that in Lower middle income?
Your answer should be very brief. 158.17. What is the ratio of the Aid flow from UN agencies (US$) of 2008 in Least developed countries to that in Lower middle income?
Keep it short and to the point. 9.88. What is the ratio of the Aid flow from UN agencies (US$) in 2009 in Least developed countries to that in Lower middle income?
Give a very brief answer. 8.44. What is the ratio of the Aid flow from UN agencies (US$) of 2010 in Least developed countries to that in Lower middle income?
Keep it short and to the point. 9.36. What is the ratio of the Aid flow from UN agencies (US$) of 2008 in Least developed countries to that in Sub-Saharan Africa (all income levels)?
Give a very brief answer. 0.9. What is the ratio of the Aid flow from UN agencies (US$) of 2009 in Least developed countries to that in Sub-Saharan Africa (all income levels)?
Offer a terse response. 0.93. What is the ratio of the Aid flow from UN agencies (US$) in 2010 in Least developed countries to that in Sub-Saharan Africa (all income levels)?
Ensure brevity in your answer.  1.17. What is the ratio of the Aid flow from UN agencies (US$) of 2008 in Least developed countries to that in Sub-Saharan Africa (developing only)?
Offer a terse response. 0.9. What is the ratio of the Aid flow from UN agencies (US$) of 2009 in Least developed countries to that in Sub-Saharan Africa (developing only)?
Ensure brevity in your answer.  0.93. What is the ratio of the Aid flow from UN agencies (US$) in 2010 in Least developed countries to that in Sub-Saharan Africa (developing only)?
Make the answer very short. 1.17. What is the ratio of the Aid flow from UN agencies (US$) of 2007 in Low income to that in Lower middle income?
Make the answer very short. 158.17. What is the ratio of the Aid flow from UN agencies (US$) of 2008 in Low income to that in Lower middle income?
Offer a terse response. 9.98. What is the ratio of the Aid flow from UN agencies (US$) of 2009 in Low income to that in Lower middle income?
Your response must be concise. 8.48. What is the ratio of the Aid flow from UN agencies (US$) of 2010 in Low income to that in Lower middle income?
Keep it short and to the point. 8.91. What is the ratio of the Aid flow from UN agencies (US$) of 2007 in Low income to that in Sub-Saharan Africa (all income levels)?
Provide a short and direct response. 0.99. What is the ratio of the Aid flow from UN agencies (US$) in 2008 in Low income to that in Sub-Saharan Africa (all income levels)?
Provide a succinct answer. 0.91. What is the ratio of the Aid flow from UN agencies (US$) of 2009 in Low income to that in Sub-Saharan Africa (all income levels)?
Provide a short and direct response. 0.94. What is the ratio of the Aid flow from UN agencies (US$) in 2010 in Low income to that in Sub-Saharan Africa (all income levels)?
Provide a short and direct response. 1.11. What is the ratio of the Aid flow from UN agencies (US$) in 2008 in Low income to that in Sub-Saharan Africa (developing only)?
Your answer should be compact. 0.91. What is the ratio of the Aid flow from UN agencies (US$) in 2009 in Low income to that in Sub-Saharan Africa (developing only)?
Offer a very short reply. 0.94. What is the ratio of the Aid flow from UN agencies (US$) in 2010 in Low income to that in Sub-Saharan Africa (developing only)?
Give a very brief answer. 1.11. What is the ratio of the Aid flow from UN agencies (US$) of 2007 in Lower middle income to that in Sub-Saharan Africa (all income levels)?
Ensure brevity in your answer.  0.01. What is the ratio of the Aid flow from UN agencies (US$) in 2008 in Lower middle income to that in Sub-Saharan Africa (all income levels)?
Keep it short and to the point. 0.09. What is the ratio of the Aid flow from UN agencies (US$) of 2009 in Lower middle income to that in Sub-Saharan Africa (all income levels)?
Make the answer very short. 0.11. What is the ratio of the Aid flow from UN agencies (US$) in 2010 in Lower middle income to that in Sub-Saharan Africa (all income levels)?
Provide a succinct answer. 0.12. What is the ratio of the Aid flow from UN agencies (US$) of 2007 in Lower middle income to that in Sub-Saharan Africa (developing only)?
Your answer should be very brief. 0.01. What is the ratio of the Aid flow from UN agencies (US$) of 2008 in Lower middle income to that in Sub-Saharan Africa (developing only)?
Your response must be concise. 0.09. What is the ratio of the Aid flow from UN agencies (US$) of 2009 in Lower middle income to that in Sub-Saharan Africa (developing only)?
Ensure brevity in your answer.  0.11. What is the ratio of the Aid flow from UN agencies (US$) in 2010 in Lower middle income to that in Sub-Saharan Africa (developing only)?
Offer a terse response. 0.12. What is the ratio of the Aid flow from UN agencies (US$) in 2007 in Sub-Saharan Africa (all income levels) to that in Sub-Saharan Africa (developing only)?
Your response must be concise. 1. What is the difference between the highest and the second highest Aid flow from UN agencies (US$) of 2007?
Provide a succinct answer. 0. What is the difference between the highest and the second highest Aid flow from UN agencies (US$) in 2009?
Your response must be concise. 4.00e+05. What is the difference between the highest and the second highest Aid flow from UN agencies (US$) in 2010?
Your answer should be compact. 2.32e+06. What is the difference between the highest and the lowest Aid flow from UN agencies (US$) of 2007?
Offer a very short reply. 9.49e+06. What is the difference between the highest and the lowest Aid flow from UN agencies (US$) in 2008?
Ensure brevity in your answer.  3.05e+07. What is the difference between the highest and the lowest Aid flow from UN agencies (US$) in 2009?
Your answer should be compact. 3.66e+07. What is the difference between the highest and the lowest Aid flow from UN agencies (US$) in 2010?
Keep it short and to the point. 4.30e+07. 